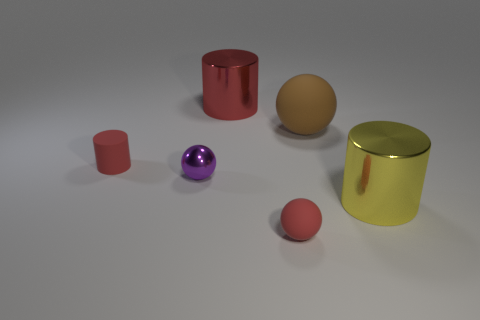The small metal ball is what color?
Your answer should be very brief. Purple. There is a big metallic thing that is the same color as the small rubber sphere; what is its shape?
Offer a terse response. Cylinder. There is a cylinder that is the same material as the big yellow thing; what size is it?
Provide a short and direct response. Large. How many objects are shiny objects that are right of the large red metal thing or big blue objects?
Offer a very short reply. 1. Are there the same number of small purple shiny things that are to the left of the tiny metal thing and big objects that are in front of the big red metal cylinder?
Keep it short and to the point. No. Do the metallic cylinder in front of the small rubber cylinder and the shiny cylinder that is behind the small shiny ball have the same size?
Give a very brief answer. Yes. How many balls are either green matte objects or large rubber things?
Ensure brevity in your answer.  1. How many rubber things are either purple spheres or tiny cyan balls?
Provide a short and direct response. 0. The brown matte thing that is the same shape as the tiny purple object is what size?
Your answer should be compact. Large. Does the metallic ball have the same size as the red rubber thing to the right of the purple shiny thing?
Offer a very short reply. Yes. 